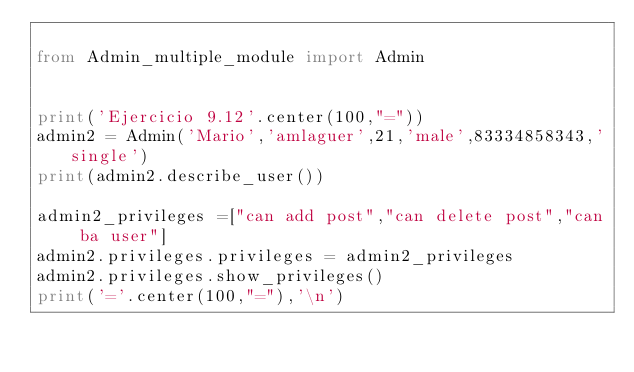<code> <loc_0><loc_0><loc_500><loc_500><_Python_>
from Admin_multiple_module import Admin


print('Ejercicio 9.12'.center(100,"="))
admin2 = Admin('Mario','amlaguer',21,'male',83334858343,'single')
print(admin2.describe_user())

admin2_privileges =["can add post","can delete post","can ba user"]
admin2.privileges.privileges = admin2_privileges
admin2.privileges.show_privileges()
print('='.center(100,"="),'\n')
</code> 